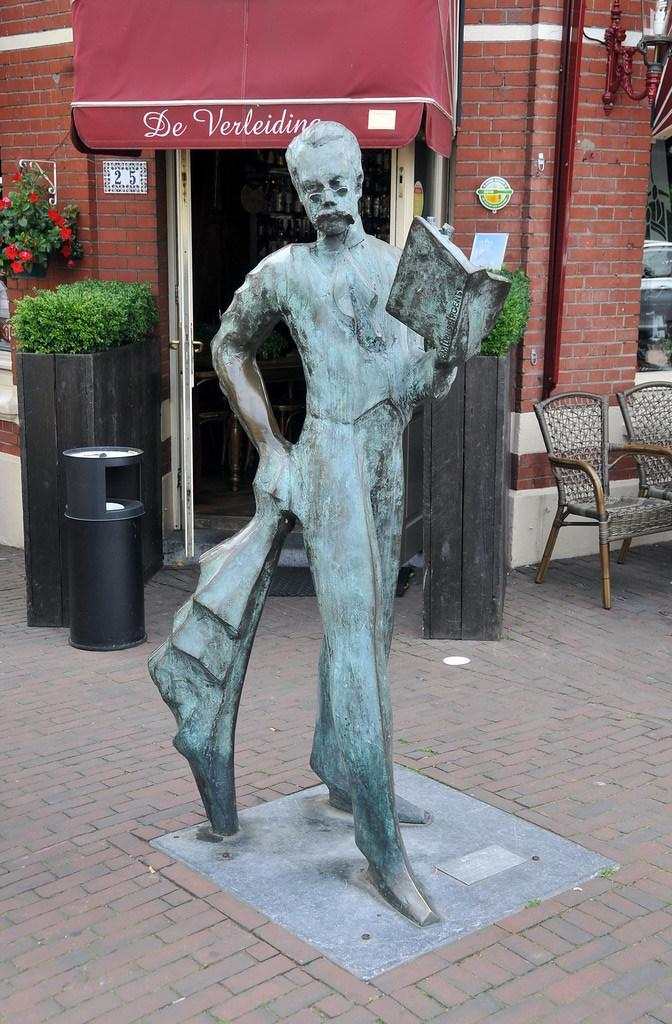What is the main subject of the image? There is a statue in the image. What is the statue holding in its hand? The statue has a book in one of its hands. What can be seen in the background of the image? In the background of the image, there is a bin, house plants, a flower pot, a wall, pipelines, chairs, and a door. What type of toy can be seen in the statue's other hand? There is no toy present in the image; the statue is holding a book in one of its hands. Can you describe the vase that is placed on the statue's head? There is no vase present on the statue's head in the image. 